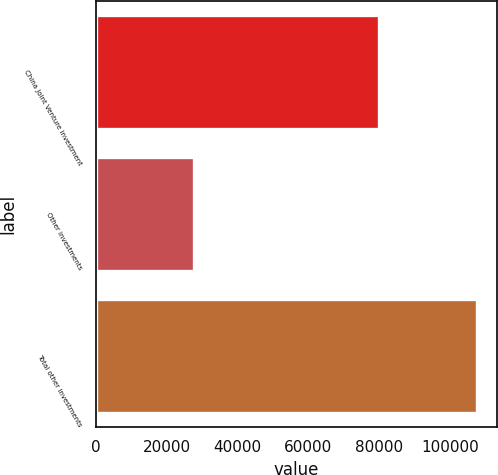Convert chart to OTSL. <chart><loc_0><loc_0><loc_500><loc_500><bar_chart><fcel>China Joint Venture investment<fcel>Other investments<fcel>Total other investments<nl><fcel>79940<fcel>27762<fcel>107702<nl></chart> 